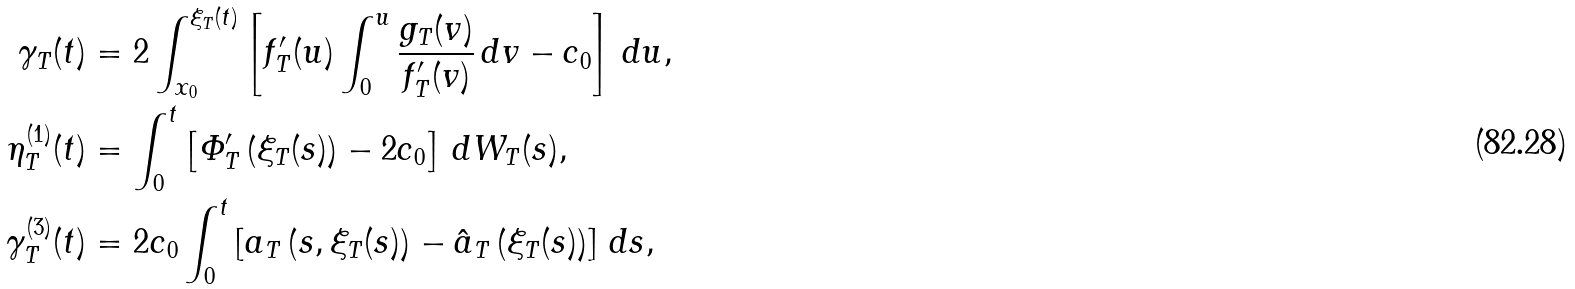<formula> <loc_0><loc_0><loc_500><loc_500>\gamma _ { T } ( t ) & = 2 \int _ { x _ { 0 } } ^ { \xi _ { T } ( t ) } \left [ f ^ { \prime } _ { T } ( u ) \int _ { 0 } ^ { u } \frac { g _ { T } ( v ) } { f ^ { \prime } _ { T } ( v ) } \, d v - c _ { 0 } \right ] \, d u , \\ \eta ^ { ( 1 ) } _ { T } ( t ) & = \int _ { 0 } ^ { t } \left [ \varPhi ^ { \prime } _ { T } \left ( \xi _ { T } ( s ) \right ) - 2 c _ { 0 } \right ] \, d W _ { T } ( s ) , \\ \gamma ^ { ( 3 ) } _ { T } ( t ) & = 2 c _ { 0 } \int _ { 0 } ^ { t } \left [ a _ { T } \left ( s , \xi _ { T } ( s ) \right ) - \hat { a } _ { T } \left ( \xi _ { T } ( s ) \right ) \right ] \, d s ,</formula> 